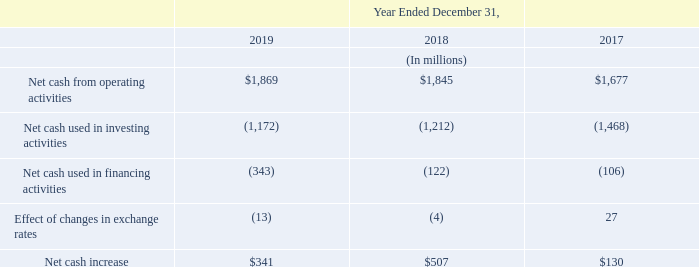Net cash from operating activities. Net cash from operating activities is the sum of (i) net income (loss) adjusted for non-cash items and (ii) changes in net working capital. The net cash from operating activities in 2019 was $1,869 million, increasing compared to $1,845 million in the prior year, mainly due to more favorable changes in net working capital, compensating lower net income.
Net cash used in investing activities. Investing activities used $1,172 million of cash in 2019, decreasing from $1,212 million in the prior year. Payments for purchase of tangible assets, net of proceeds, totaled $1,174 million, compared to $1,262 million registered in the prior-year period. The 2019 numbers also included the proceeds from matured marketable securities of $200 million and the net cash outflow of $127 million for the acquisition of Norstel.
Net cash used in financing activities. Net cash used in financing activities was $343 million for 2019, compared to the $122 million used in 2018. The 2019 amount included $281 million proceeds from long-term debt, $144 million of long-term debt repayment, $250 million of repurchase of common stock and $214 million of dividends paid to stockholders.
What led to increase in net cash from operating activities in 2019? Mainly due to more favorable changes in net working capital, compensating lower net income. What was the value of proceeds from matured marketable securities in 2019? $200 million. What was the value of Net cash used in financing activities  in 2019? $343 million. What is the increase/ (decrease) in Net cash from operating activities from the period 2017 to 2019?
Answer scale should be: million. 1,869-1,677
Answer: 192. What is the increase/ (decrease) in Net cash used in investing activities from the period 2017 to 2019?
Answer scale should be: million. 1,172-1,468
Answer: -296. What is the increase/ (decrease) in Net cash used in financing activities from the period 2017 to 2019?
Answer scale should be: million. 343-106
Answer: 237. 